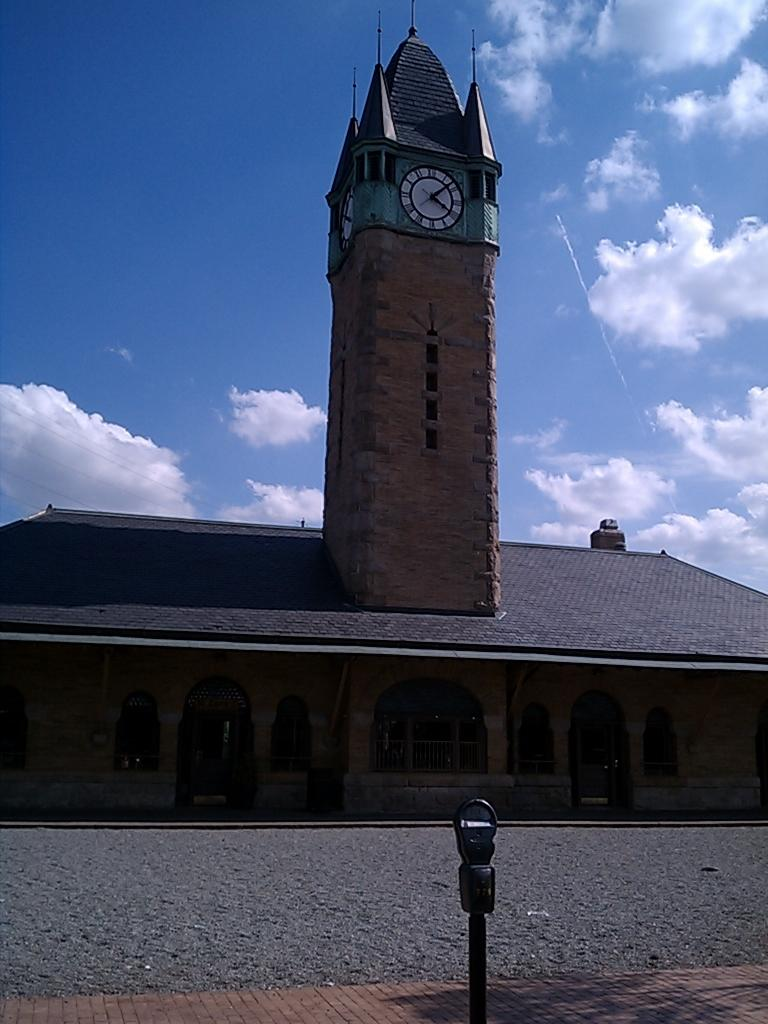What type of structure is the main subject of the image? There is a clock tower in the image. Are there any other timekeeping devices visible in the image? Yes, there are clocks in the image. What else can be seen in the image related to parking or transportation? There is a parking meter in the image. What is the condition of the sky in the image? The sky is cloudy in the image. What type of surface is visible in the image? There is a road in the image. What type of utensil is used to eat the border in the image? There is: There is no border or utensil present in the image. 